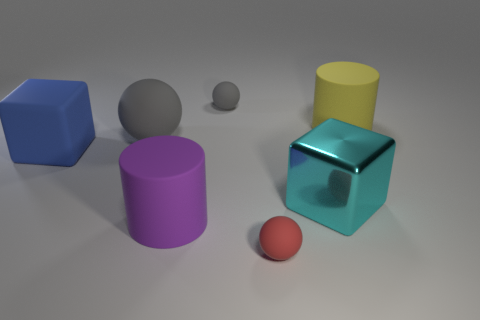Subtract all red rubber spheres. How many spheres are left? 2 Subtract all red spheres. How many spheres are left? 2 Subtract all brown cubes. How many gray spheres are left? 2 Add 3 tiny green metal blocks. How many objects exist? 10 Subtract all blocks. How many objects are left? 5 Subtract 1 cylinders. How many cylinders are left? 1 Subtract 1 gray spheres. How many objects are left? 6 Subtract all purple cylinders. Subtract all gray balls. How many cylinders are left? 1 Subtract all big cylinders. Subtract all large shiny objects. How many objects are left? 4 Add 6 big cyan cubes. How many big cyan cubes are left? 7 